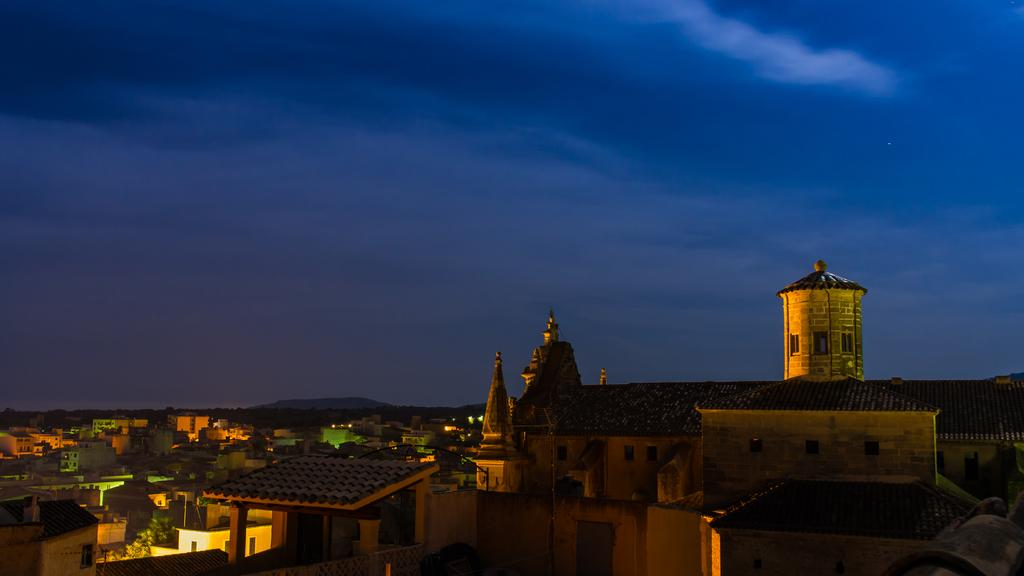What structures are located at the bottom of the image? There are buildings at the bottom of the image. What type of vegetation is present at the bottom of the image? Trees are present at the bottom of the image. What architectural features can be seen at the bottom of the image? Walls and windows are visible at the bottom of the image. What can be seen in the background of the image? There is a hill and the sky visible in the background of the image. What type of jeans is the hill wearing in the image? The hill is not wearing jeans or any other clothing, as it is a natural formation and not a person. 